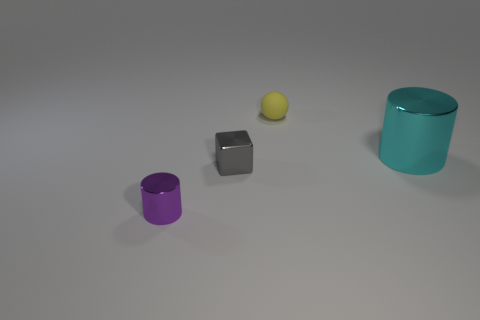Is there anything else that has the same size as the cyan shiny thing?
Your answer should be very brief. No. The cylinder in front of the metal cylinder on the right side of the cube is what color?
Offer a terse response. Purple. Are there fewer big things in front of the big metallic cylinder than small cubes that are in front of the small yellow object?
Offer a very short reply. Yes. What number of things are tiny things behind the big cyan shiny thing or tiny green shiny spheres?
Provide a succinct answer. 1. There is a cylinder that is to the right of the purple shiny cylinder; is it the same size as the tiny metal cube?
Make the answer very short. No. Is the number of yellow balls that are on the left side of the tiny metallic cube less than the number of small cyan shiny cubes?
Offer a terse response. No. There is a yellow object that is the same size as the gray block; what is its material?
Give a very brief answer. Rubber. How many big things are either blue metallic spheres or yellow spheres?
Provide a succinct answer. 0. How many objects are metallic cylinders that are right of the gray object or metal things on the right side of the sphere?
Your answer should be compact. 1. Is the number of yellow rubber things less than the number of small metallic objects?
Your answer should be compact. Yes. 